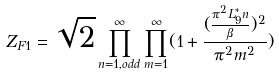<formula> <loc_0><loc_0><loc_500><loc_500>Z _ { F 1 } = \sqrt { 2 } \prod _ { n = 1 , o d d } ^ { \infty } \prod _ { m = 1 } ^ { \infty } ( 1 + \frac { ( \frac { \pi ^ { 2 } L _ { 9 } ^ { \ast } n } { \beta } ) ^ { 2 } } { \pi ^ { 2 } m ^ { 2 } } )</formula> 